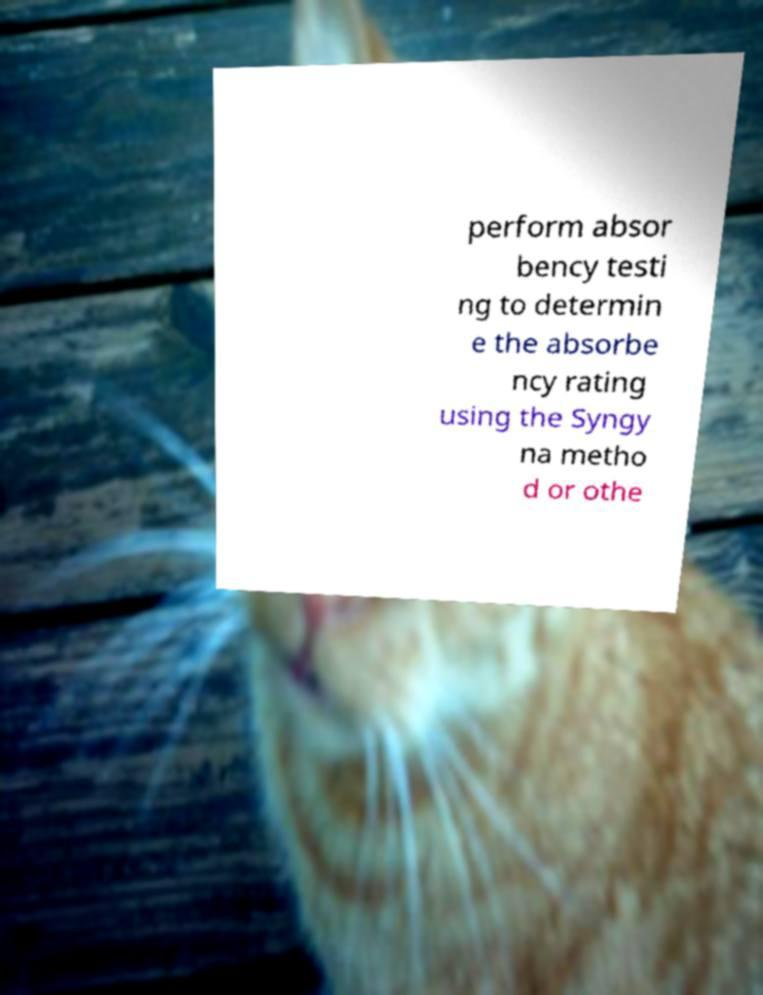Could you extract and type out the text from this image? perform absor bency testi ng to determin e the absorbe ncy rating using the Syngy na metho d or othe 